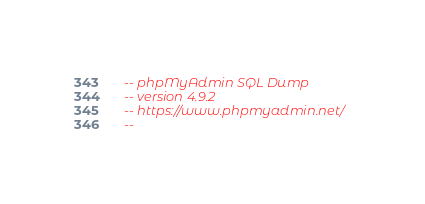<code> <loc_0><loc_0><loc_500><loc_500><_SQL_>-- phpMyAdmin SQL Dump
-- version 4.9.2
-- https://www.phpmyadmin.net/
--</code> 